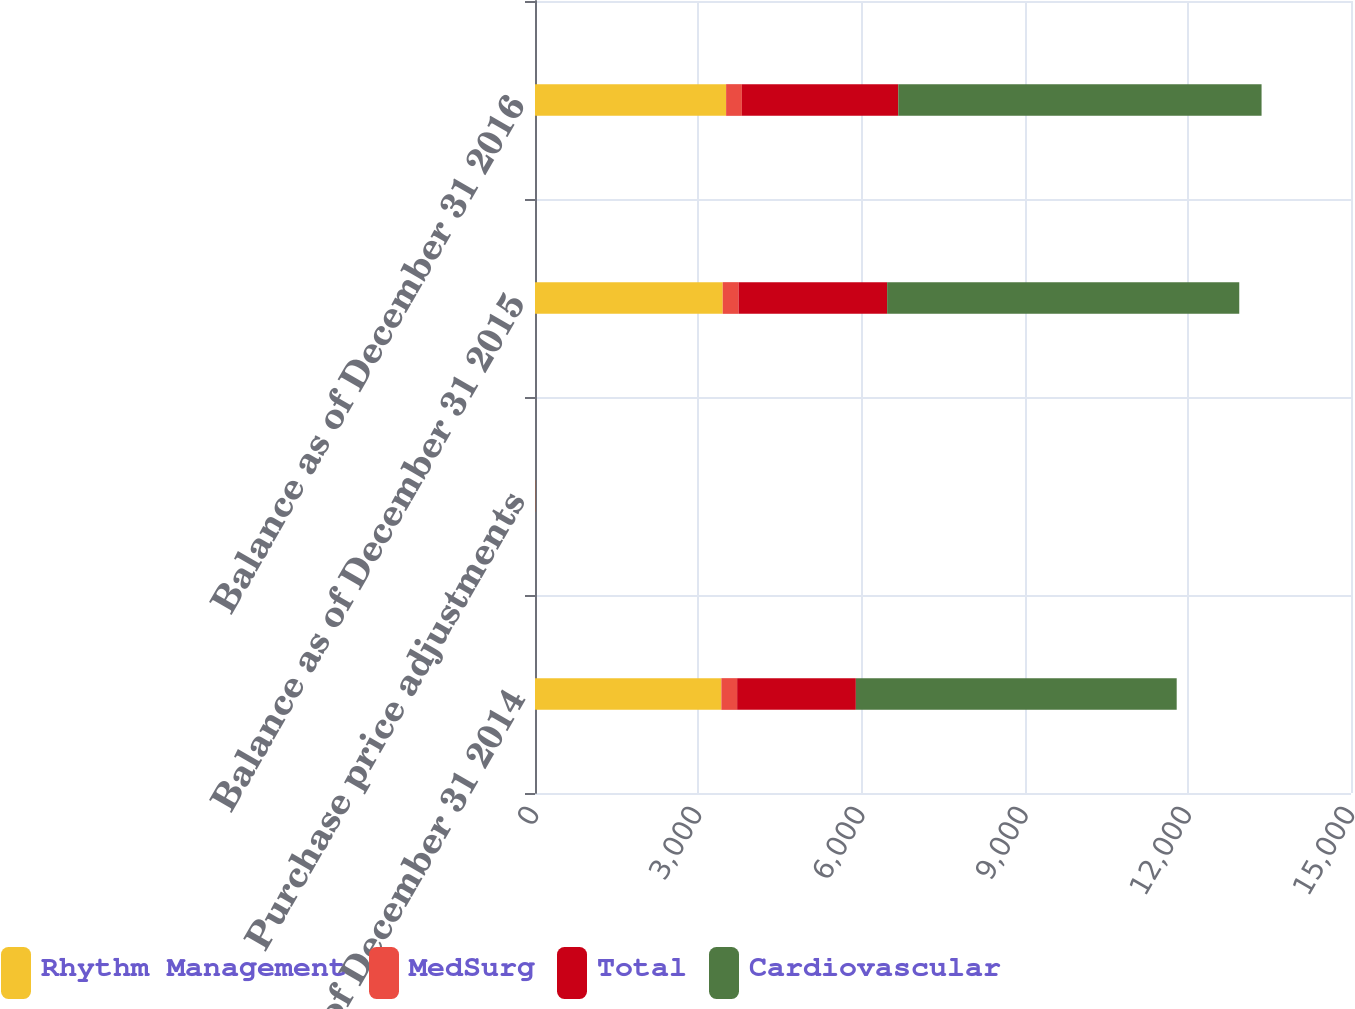<chart> <loc_0><loc_0><loc_500><loc_500><stacked_bar_chart><ecel><fcel>Balance as of December 31 2014<fcel>Purchase price adjustments<fcel>Balance as of December 31 2015<fcel>Balance as of December 31 2016<nl><fcel>Rhythm Management<fcel>3426<fcel>2<fcel>3451<fcel>3513<nl><fcel>MedSurg<fcel>290<fcel>2<fcel>292<fcel>290<nl><fcel>Total<fcel>2182<fcel>2<fcel>2730<fcel>2875<nl><fcel>Cardiovascular<fcel>5898<fcel>2<fcel>6473<fcel>6678<nl></chart> 